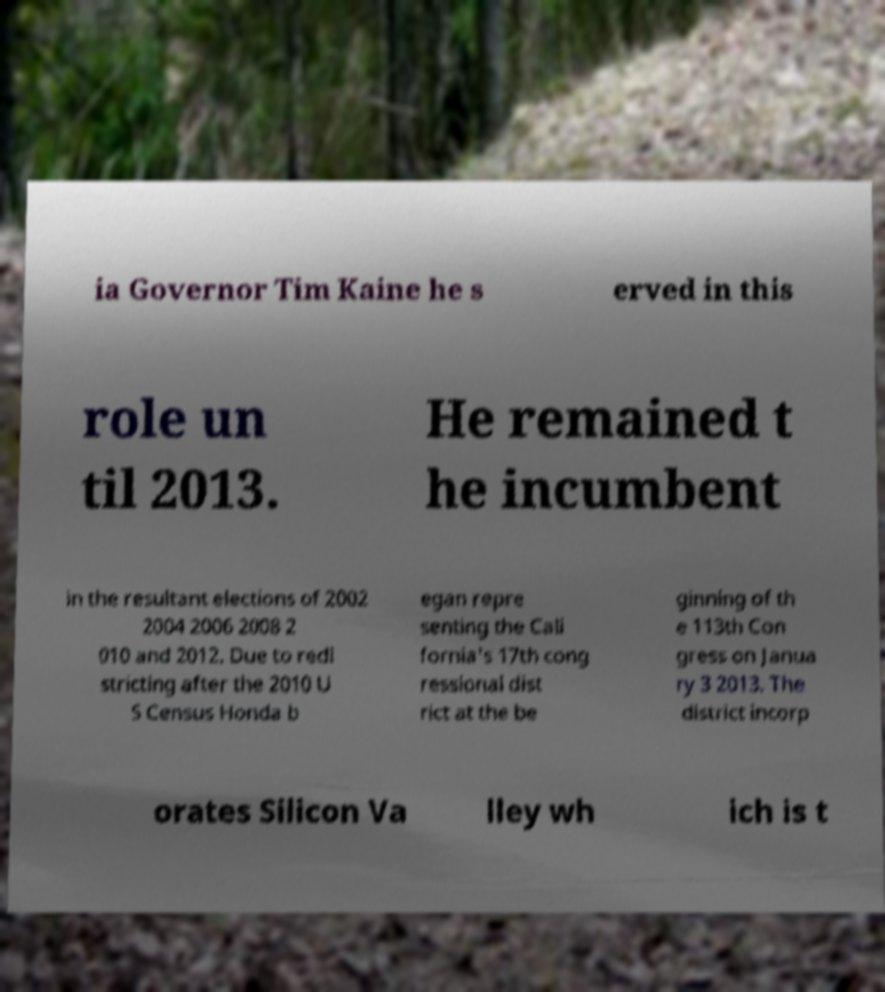For documentation purposes, I need the text within this image transcribed. Could you provide that? ia Governor Tim Kaine he s erved in this role un til 2013. He remained t he incumbent in the resultant elections of 2002 2004 2006 2008 2 010 and 2012. Due to redi stricting after the 2010 U S Census Honda b egan repre senting the Cali fornia's 17th cong ressional dist rict at the be ginning of th e 113th Con gress on Janua ry 3 2013. The district incorp orates Silicon Va lley wh ich is t 